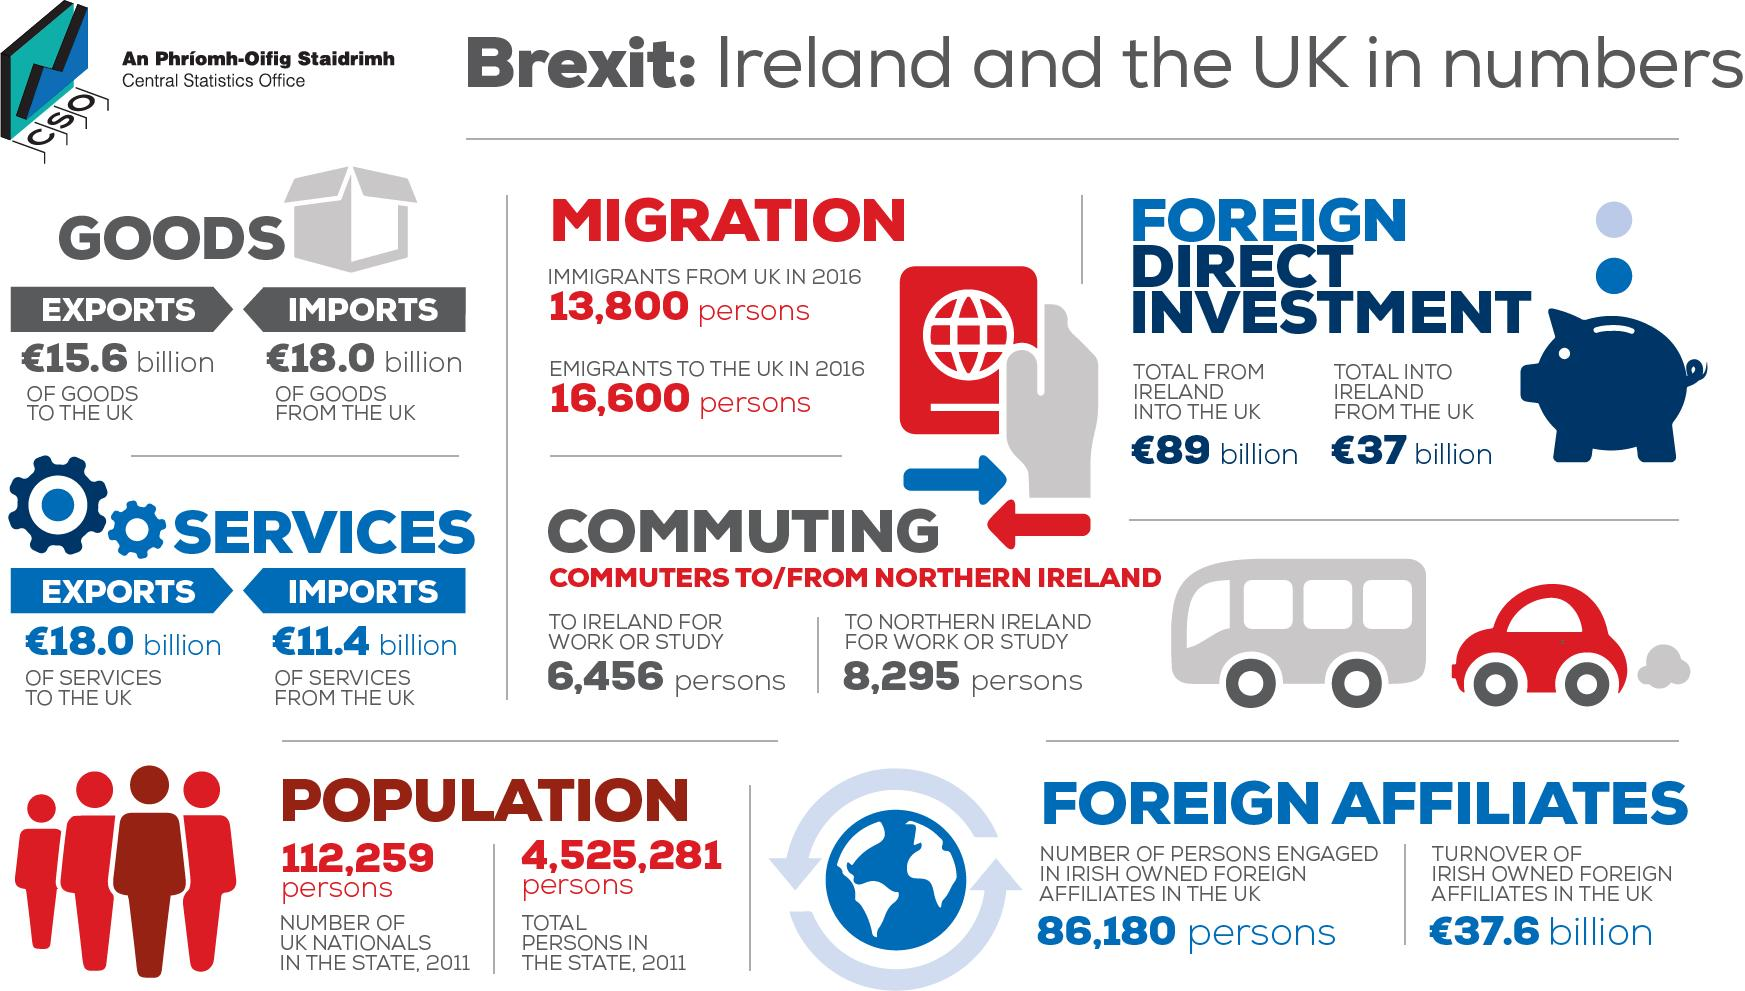Point out several critical features in this image. According to recent data, the amount of Foreign Direct Investment from the United Kingdom into Ireland is approximately 37 billion pounds. The import of services from the UK totaled 11.4 billion pounds in the given amount. The population of Ireland, without UK nationals in the state, is approximately 4,413,022. The quantity of goods imported from the UK was approximately 18.0 billion pounds. In 2016, the number of emigrants to the UK was 16,600. 